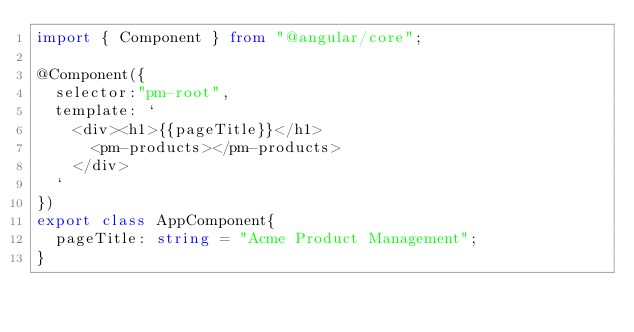Convert code to text. <code><loc_0><loc_0><loc_500><loc_500><_TypeScript_>import { Component } from "@angular/core";

@Component({
  selector:"pm-root",
  template: `
    <div><h1>{{pageTitle}}</h1>
      <pm-products></pm-products>
    </div>
  `
})
export class AppComponent{
  pageTitle: string = "Acme Product Management";
}</code> 